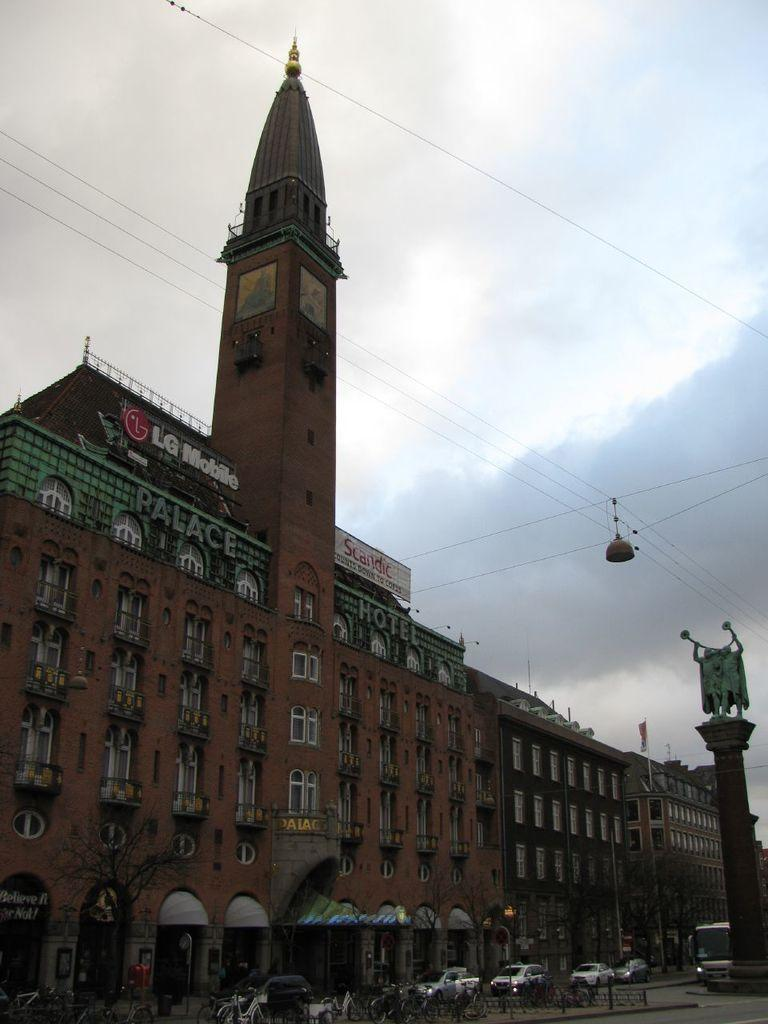What type of structures can be seen in the image? There are buildings in the image. What is happening on the road in the image? Vehicles are present on the road in the image. What is the statue in the image depicting? The statue in the image is a specific object or figure. What else can be seen on the ground in the image? Other objects are visible on the ground in the image. What is visible in the background of the image? Wires and the sky are visible in the background of the image. What book is the statue reading in the image? There is no statue reading a book in the image. 